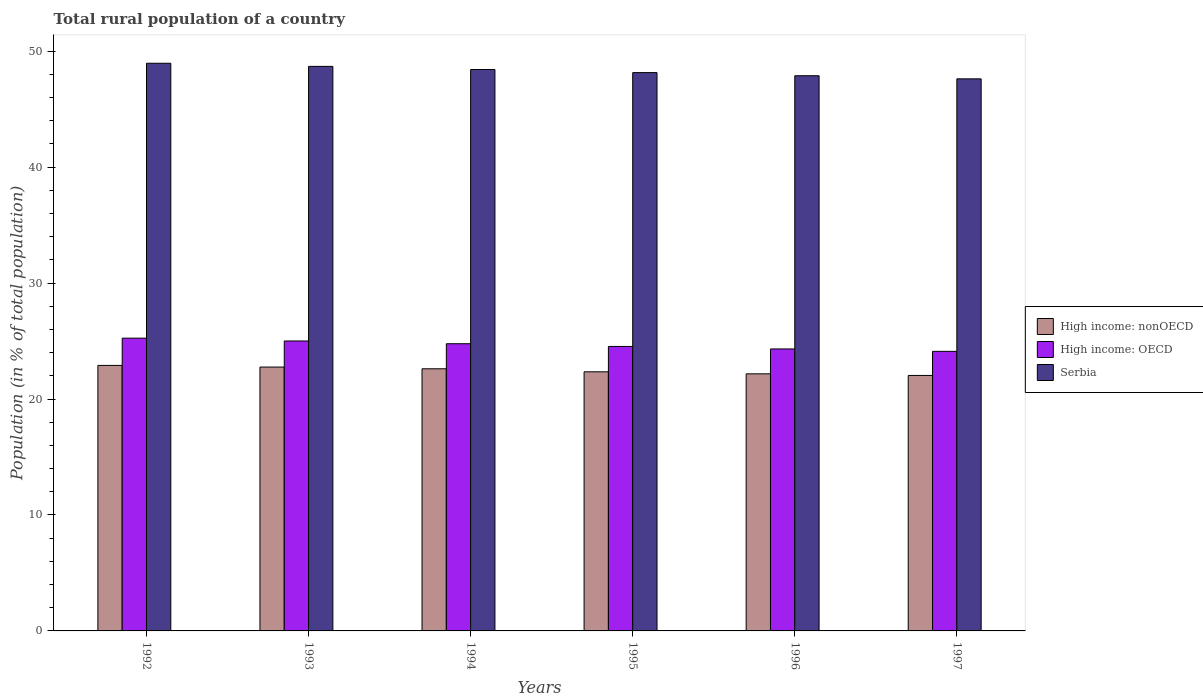How many different coloured bars are there?
Keep it short and to the point. 3. How many bars are there on the 5th tick from the left?
Your answer should be very brief. 3. What is the label of the 2nd group of bars from the left?
Provide a short and direct response. 1993. In how many cases, is the number of bars for a given year not equal to the number of legend labels?
Give a very brief answer. 0. What is the rural population in High income: OECD in 1994?
Provide a succinct answer. 24.77. Across all years, what is the maximum rural population in Serbia?
Give a very brief answer. 48.96. Across all years, what is the minimum rural population in High income: nonOECD?
Give a very brief answer. 22.04. In which year was the rural population in High income: OECD maximum?
Your answer should be very brief. 1992. In which year was the rural population in High income: nonOECD minimum?
Your answer should be very brief. 1997. What is the total rural population in High income: OECD in the graph?
Offer a terse response. 148. What is the difference between the rural population in High income: nonOECD in 1995 and that in 1996?
Ensure brevity in your answer.  0.17. What is the difference between the rural population in High income: OECD in 1993 and the rural population in Serbia in 1995?
Ensure brevity in your answer.  -23.15. What is the average rural population in High income: nonOECD per year?
Your answer should be compact. 22.47. In the year 1996, what is the difference between the rural population in Serbia and rural population in High income: OECD?
Offer a terse response. 23.56. What is the ratio of the rural population in Serbia in 1995 to that in 1996?
Offer a very short reply. 1.01. What is the difference between the highest and the second highest rural population in High income: nonOECD?
Offer a terse response. 0.14. What is the difference between the highest and the lowest rural population in High income: nonOECD?
Your answer should be very brief. 0.87. Is the sum of the rural population in Serbia in 1993 and 1995 greater than the maximum rural population in High income: nonOECD across all years?
Provide a short and direct response. Yes. What does the 1st bar from the left in 1993 represents?
Provide a succinct answer. High income: nonOECD. What does the 2nd bar from the right in 1995 represents?
Offer a terse response. High income: OECD. Are all the bars in the graph horizontal?
Your response must be concise. No. What is the difference between two consecutive major ticks on the Y-axis?
Give a very brief answer. 10. Does the graph contain any zero values?
Your answer should be compact. No. How many legend labels are there?
Give a very brief answer. 3. What is the title of the graph?
Provide a short and direct response. Total rural population of a country. Does "Austria" appear as one of the legend labels in the graph?
Make the answer very short. No. What is the label or title of the X-axis?
Ensure brevity in your answer.  Years. What is the label or title of the Y-axis?
Ensure brevity in your answer.  Population (in % of total population). What is the Population (in % of total population) of High income: nonOECD in 1992?
Provide a succinct answer. 22.9. What is the Population (in % of total population) of High income: OECD in 1992?
Give a very brief answer. 25.25. What is the Population (in % of total population) of Serbia in 1992?
Your answer should be very brief. 48.96. What is the Population (in % of total population) of High income: nonOECD in 1993?
Provide a short and direct response. 22.76. What is the Population (in % of total population) in High income: OECD in 1993?
Your answer should be very brief. 25.01. What is the Population (in % of total population) in Serbia in 1993?
Provide a short and direct response. 48.69. What is the Population (in % of total population) in High income: nonOECD in 1994?
Offer a very short reply. 22.61. What is the Population (in % of total population) of High income: OECD in 1994?
Provide a short and direct response. 24.77. What is the Population (in % of total population) in Serbia in 1994?
Your response must be concise. 48.42. What is the Population (in % of total population) in High income: nonOECD in 1995?
Keep it short and to the point. 22.35. What is the Population (in % of total population) of High income: OECD in 1995?
Provide a short and direct response. 24.54. What is the Population (in % of total population) in Serbia in 1995?
Your response must be concise. 48.16. What is the Population (in % of total population) of High income: nonOECD in 1996?
Provide a short and direct response. 22.18. What is the Population (in % of total population) of High income: OECD in 1996?
Ensure brevity in your answer.  24.32. What is the Population (in % of total population) of Serbia in 1996?
Provide a succinct answer. 47.89. What is the Population (in % of total population) of High income: nonOECD in 1997?
Give a very brief answer. 22.04. What is the Population (in % of total population) in High income: OECD in 1997?
Offer a very short reply. 24.11. What is the Population (in % of total population) in Serbia in 1997?
Make the answer very short. 47.62. Across all years, what is the maximum Population (in % of total population) in High income: nonOECD?
Offer a terse response. 22.9. Across all years, what is the maximum Population (in % of total population) in High income: OECD?
Keep it short and to the point. 25.25. Across all years, what is the maximum Population (in % of total population) of Serbia?
Keep it short and to the point. 48.96. Across all years, what is the minimum Population (in % of total population) of High income: nonOECD?
Your answer should be very brief. 22.04. Across all years, what is the minimum Population (in % of total population) in High income: OECD?
Your answer should be very brief. 24.11. Across all years, what is the minimum Population (in % of total population) in Serbia?
Your answer should be compact. 47.62. What is the total Population (in % of total population) in High income: nonOECD in the graph?
Your answer should be very brief. 134.83. What is the total Population (in % of total population) of High income: OECD in the graph?
Offer a very short reply. 148. What is the total Population (in % of total population) of Serbia in the graph?
Make the answer very short. 289.74. What is the difference between the Population (in % of total population) of High income: nonOECD in 1992 and that in 1993?
Offer a terse response. 0.14. What is the difference between the Population (in % of total population) in High income: OECD in 1992 and that in 1993?
Keep it short and to the point. 0.24. What is the difference between the Population (in % of total population) in Serbia in 1992 and that in 1993?
Provide a short and direct response. 0.27. What is the difference between the Population (in % of total population) in High income: nonOECD in 1992 and that in 1994?
Provide a short and direct response. 0.29. What is the difference between the Population (in % of total population) in High income: OECD in 1992 and that in 1994?
Make the answer very short. 0.48. What is the difference between the Population (in % of total population) of Serbia in 1992 and that in 1994?
Make the answer very short. 0.54. What is the difference between the Population (in % of total population) in High income: nonOECD in 1992 and that in 1995?
Offer a terse response. 0.55. What is the difference between the Population (in % of total population) of High income: OECD in 1992 and that in 1995?
Your response must be concise. 0.71. What is the difference between the Population (in % of total population) in Serbia in 1992 and that in 1995?
Give a very brief answer. 0.81. What is the difference between the Population (in % of total population) in High income: nonOECD in 1992 and that in 1996?
Provide a short and direct response. 0.73. What is the difference between the Population (in % of total population) in High income: OECD in 1992 and that in 1996?
Provide a succinct answer. 0.93. What is the difference between the Population (in % of total population) of Serbia in 1992 and that in 1996?
Your response must be concise. 1.08. What is the difference between the Population (in % of total population) of High income: nonOECD in 1992 and that in 1997?
Your response must be concise. 0.87. What is the difference between the Population (in % of total population) of High income: OECD in 1992 and that in 1997?
Offer a terse response. 1.14. What is the difference between the Population (in % of total population) of Serbia in 1992 and that in 1997?
Provide a succinct answer. 1.34. What is the difference between the Population (in % of total population) of High income: nonOECD in 1993 and that in 1994?
Make the answer very short. 0.15. What is the difference between the Population (in % of total population) of High income: OECD in 1993 and that in 1994?
Offer a very short reply. 0.24. What is the difference between the Population (in % of total population) of Serbia in 1993 and that in 1994?
Keep it short and to the point. 0.27. What is the difference between the Population (in % of total population) in High income: nonOECD in 1993 and that in 1995?
Offer a very short reply. 0.41. What is the difference between the Population (in % of total population) in High income: OECD in 1993 and that in 1995?
Offer a very short reply. 0.47. What is the difference between the Population (in % of total population) in Serbia in 1993 and that in 1995?
Your answer should be very brief. 0.54. What is the difference between the Population (in % of total population) in High income: nonOECD in 1993 and that in 1996?
Keep it short and to the point. 0.58. What is the difference between the Population (in % of total population) of High income: OECD in 1993 and that in 1996?
Ensure brevity in your answer.  0.69. What is the difference between the Population (in % of total population) in Serbia in 1993 and that in 1996?
Offer a very short reply. 0.81. What is the difference between the Population (in % of total population) in High income: nonOECD in 1993 and that in 1997?
Provide a short and direct response. 0.72. What is the difference between the Population (in % of total population) of High income: OECD in 1993 and that in 1997?
Offer a terse response. 0.89. What is the difference between the Population (in % of total population) in Serbia in 1993 and that in 1997?
Your answer should be compact. 1.08. What is the difference between the Population (in % of total population) in High income: nonOECD in 1994 and that in 1995?
Ensure brevity in your answer.  0.26. What is the difference between the Population (in % of total population) in High income: OECD in 1994 and that in 1995?
Provide a succinct answer. 0.23. What is the difference between the Population (in % of total population) of Serbia in 1994 and that in 1995?
Give a very brief answer. 0.27. What is the difference between the Population (in % of total population) of High income: nonOECD in 1994 and that in 1996?
Your response must be concise. 0.43. What is the difference between the Population (in % of total population) in High income: OECD in 1994 and that in 1996?
Keep it short and to the point. 0.45. What is the difference between the Population (in % of total population) in Serbia in 1994 and that in 1996?
Give a very brief answer. 0.54. What is the difference between the Population (in % of total population) in High income: nonOECD in 1994 and that in 1997?
Keep it short and to the point. 0.57. What is the difference between the Population (in % of total population) of High income: OECD in 1994 and that in 1997?
Ensure brevity in your answer.  0.66. What is the difference between the Population (in % of total population) in Serbia in 1994 and that in 1997?
Your answer should be compact. 0.81. What is the difference between the Population (in % of total population) of High income: nonOECD in 1995 and that in 1996?
Keep it short and to the point. 0.17. What is the difference between the Population (in % of total population) in High income: OECD in 1995 and that in 1996?
Your response must be concise. 0.22. What is the difference between the Population (in % of total population) in Serbia in 1995 and that in 1996?
Your answer should be compact. 0.27. What is the difference between the Population (in % of total population) of High income: nonOECD in 1995 and that in 1997?
Ensure brevity in your answer.  0.31. What is the difference between the Population (in % of total population) in High income: OECD in 1995 and that in 1997?
Offer a terse response. 0.42. What is the difference between the Population (in % of total population) in Serbia in 1995 and that in 1997?
Your response must be concise. 0.54. What is the difference between the Population (in % of total population) in High income: nonOECD in 1996 and that in 1997?
Offer a very short reply. 0.14. What is the difference between the Population (in % of total population) of High income: OECD in 1996 and that in 1997?
Your response must be concise. 0.21. What is the difference between the Population (in % of total population) of Serbia in 1996 and that in 1997?
Provide a succinct answer. 0.27. What is the difference between the Population (in % of total population) in High income: nonOECD in 1992 and the Population (in % of total population) in High income: OECD in 1993?
Your answer should be very brief. -2.11. What is the difference between the Population (in % of total population) in High income: nonOECD in 1992 and the Population (in % of total population) in Serbia in 1993?
Ensure brevity in your answer.  -25.79. What is the difference between the Population (in % of total population) of High income: OECD in 1992 and the Population (in % of total population) of Serbia in 1993?
Make the answer very short. -23.44. What is the difference between the Population (in % of total population) of High income: nonOECD in 1992 and the Population (in % of total population) of High income: OECD in 1994?
Offer a very short reply. -1.87. What is the difference between the Population (in % of total population) of High income: nonOECD in 1992 and the Population (in % of total population) of Serbia in 1994?
Your answer should be compact. -25.52. What is the difference between the Population (in % of total population) of High income: OECD in 1992 and the Population (in % of total population) of Serbia in 1994?
Keep it short and to the point. -23.17. What is the difference between the Population (in % of total population) of High income: nonOECD in 1992 and the Population (in % of total population) of High income: OECD in 1995?
Offer a very short reply. -1.64. What is the difference between the Population (in % of total population) of High income: nonOECD in 1992 and the Population (in % of total population) of Serbia in 1995?
Provide a succinct answer. -25.26. What is the difference between the Population (in % of total population) of High income: OECD in 1992 and the Population (in % of total population) of Serbia in 1995?
Your answer should be compact. -22.91. What is the difference between the Population (in % of total population) in High income: nonOECD in 1992 and the Population (in % of total population) in High income: OECD in 1996?
Provide a succinct answer. -1.42. What is the difference between the Population (in % of total population) of High income: nonOECD in 1992 and the Population (in % of total population) of Serbia in 1996?
Offer a terse response. -24.99. What is the difference between the Population (in % of total population) in High income: OECD in 1992 and the Population (in % of total population) in Serbia in 1996?
Provide a succinct answer. -22.64. What is the difference between the Population (in % of total population) in High income: nonOECD in 1992 and the Population (in % of total population) in High income: OECD in 1997?
Provide a succinct answer. -1.21. What is the difference between the Population (in % of total population) in High income: nonOECD in 1992 and the Population (in % of total population) in Serbia in 1997?
Keep it short and to the point. -24.72. What is the difference between the Population (in % of total population) in High income: OECD in 1992 and the Population (in % of total population) in Serbia in 1997?
Ensure brevity in your answer.  -22.37. What is the difference between the Population (in % of total population) of High income: nonOECD in 1993 and the Population (in % of total population) of High income: OECD in 1994?
Make the answer very short. -2.01. What is the difference between the Population (in % of total population) in High income: nonOECD in 1993 and the Population (in % of total population) in Serbia in 1994?
Offer a terse response. -25.67. What is the difference between the Population (in % of total population) in High income: OECD in 1993 and the Population (in % of total population) in Serbia in 1994?
Provide a succinct answer. -23.42. What is the difference between the Population (in % of total population) in High income: nonOECD in 1993 and the Population (in % of total population) in High income: OECD in 1995?
Give a very brief answer. -1.78. What is the difference between the Population (in % of total population) in High income: nonOECD in 1993 and the Population (in % of total population) in Serbia in 1995?
Make the answer very short. -25.4. What is the difference between the Population (in % of total population) of High income: OECD in 1993 and the Population (in % of total population) of Serbia in 1995?
Your answer should be very brief. -23.15. What is the difference between the Population (in % of total population) of High income: nonOECD in 1993 and the Population (in % of total population) of High income: OECD in 1996?
Keep it short and to the point. -1.56. What is the difference between the Population (in % of total population) of High income: nonOECD in 1993 and the Population (in % of total population) of Serbia in 1996?
Your answer should be compact. -25.13. What is the difference between the Population (in % of total population) in High income: OECD in 1993 and the Population (in % of total population) in Serbia in 1996?
Your answer should be compact. -22.88. What is the difference between the Population (in % of total population) of High income: nonOECD in 1993 and the Population (in % of total population) of High income: OECD in 1997?
Ensure brevity in your answer.  -1.36. What is the difference between the Population (in % of total population) in High income: nonOECD in 1993 and the Population (in % of total population) in Serbia in 1997?
Offer a terse response. -24.86. What is the difference between the Population (in % of total population) of High income: OECD in 1993 and the Population (in % of total population) of Serbia in 1997?
Provide a succinct answer. -22.61. What is the difference between the Population (in % of total population) of High income: nonOECD in 1994 and the Population (in % of total population) of High income: OECD in 1995?
Ensure brevity in your answer.  -1.93. What is the difference between the Population (in % of total population) in High income: nonOECD in 1994 and the Population (in % of total population) in Serbia in 1995?
Offer a very short reply. -25.55. What is the difference between the Population (in % of total population) in High income: OECD in 1994 and the Population (in % of total population) in Serbia in 1995?
Your response must be concise. -23.38. What is the difference between the Population (in % of total population) of High income: nonOECD in 1994 and the Population (in % of total population) of High income: OECD in 1996?
Keep it short and to the point. -1.71. What is the difference between the Population (in % of total population) in High income: nonOECD in 1994 and the Population (in % of total population) in Serbia in 1996?
Provide a succinct answer. -25.28. What is the difference between the Population (in % of total population) in High income: OECD in 1994 and the Population (in % of total population) in Serbia in 1996?
Offer a terse response. -23.11. What is the difference between the Population (in % of total population) of High income: nonOECD in 1994 and the Population (in % of total population) of High income: OECD in 1997?
Your answer should be very brief. -1.5. What is the difference between the Population (in % of total population) of High income: nonOECD in 1994 and the Population (in % of total population) of Serbia in 1997?
Give a very brief answer. -25.01. What is the difference between the Population (in % of total population) in High income: OECD in 1994 and the Population (in % of total population) in Serbia in 1997?
Provide a short and direct response. -22.85. What is the difference between the Population (in % of total population) in High income: nonOECD in 1995 and the Population (in % of total population) in High income: OECD in 1996?
Your response must be concise. -1.97. What is the difference between the Population (in % of total population) in High income: nonOECD in 1995 and the Population (in % of total population) in Serbia in 1996?
Give a very brief answer. -25.54. What is the difference between the Population (in % of total population) of High income: OECD in 1995 and the Population (in % of total population) of Serbia in 1996?
Offer a very short reply. -23.35. What is the difference between the Population (in % of total population) of High income: nonOECD in 1995 and the Population (in % of total population) of High income: OECD in 1997?
Offer a very short reply. -1.76. What is the difference between the Population (in % of total population) of High income: nonOECD in 1995 and the Population (in % of total population) of Serbia in 1997?
Provide a succinct answer. -25.27. What is the difference between the Population (in % of total population) in High income: OECD in 1995 and the Population (in % of total population) in Serbia in 1997?
Give a very brief answer. -23.08. What is the difference between the Population (in % of total population) of High income: nonOECD in 1996 and the Population (in % of total population) of High income: OECD in 1997?
Provide a succinct answer. -1.94. What is the difference between the Population (in % of total population) of High income: nonOECD in 1996 and the Population (in % of total population) of Serbia in 1997?
Keep it short and to the point. -25.44. What is the difference between the Population (in % of total population) in High income: OECD in 1996 and the Population (in % of total population) in Serbia in 1997?
Keep it short and to the point. -23.3. What is the average Population (in % of total population) of High income: nonOECD per year?
Offer a terse response. 22.47. What is the average Population (in % of total population) of High income: OECD per year?
Offer a very short reply. 24.67. What is the average Population (in % of total population) of Serbia per year?
Your answer should be very brief. 48.29. In the year 1992, what is the difference between the Population (in % of total population) in High income: nonOECD and Population (in % of total population) in High income: OECD?
Provide a short and direct response. -2.35. In the year 1992, what is the difference between the Population (in % of total population) of High income: nonOECD and Population (in % of total population) of Serbia?
Keep it short and to the point. -26.06. In the year 1992, what is the difference between the Population (in % of total population) of High income: OECD and Population (in % of total population) of Serbia?
Offer a terse response. -23.71. In the year 1993, what is the difference between the Population (in % of total population) of High income: nonOECD and Population (in % of total population) of High income: OECD?
Provide a succinct answer. -2.25. In the year 1993, what is the difference between the Population (in % of total population) in High income: nonOECD and Population (in % of total population) in Serbia?
Your answer should be very brief. -25.94. In the year 1993, what is the difference between the Population (in % of total population) in High income: OECD and Population (in % of total population) in Serbia?
Keep it short and to the point. -23.69. In the year 1994, what is the difference between the Population (in % of total population) of High income: nonOECD and Population (in % of total population) of High income: OECD?
Your response must be concise. -2.16. In the year 1994, what is the difference between the Population (in % of total population) in High income: nonOECD and Population (in % of total population) in Serbia?
Give a very brief answer. -25.81. In the year 1994, what is the difference between the Population (in % of total population) in High income: OECD and Population (in % of total population) in Serbia?
Provide a short and direct response. -23.65. In the year 1995, what is the difference between the Population (in % of total population) in High income: nonOECD and Population (in % of total population) in High income: OECD?
Provide a short and direct response. -2.19. In the year 1995, what is the difference between the Population (in % of total population) of High income: nonOECD and Population (in % of total population) of Serbia?
Your response must be concise. -25.81. In the year 1995, what is the difference between the Population (in % of total population) of High income: OECD and Population (in % of total population) of Serbia?
Your response must be concise. -23.62. In the year 1996, what is the difference between the Population (in % of total population) of High income: nonOECD and Population (in % of total population) of High income: OECD?
Make the answer very short. -2.15. In the year 1996, what is the difference between the Population (in % of total population) in High income: nonOECD and Population (in % of total population) in Serbia?
Provide a short and direct response. -25.71. In the year 1996, what is the difference between the Population (in % of total population) in High income: OECD and Population (in % of total population) in Serbia?
Give a very brief answer. -23.56. In the year 1997, what is the difference between the Population (in % of total population) in High income: nonOECD and Population (in % of total population) in High income: OECD?
Ensure brevity in your answer.  -2.08. In the year 1997, what is the difference between the Population (in % of total population) of High income: nonOECD and Population (in % of total population) of Serbia?
Provide a short and direct response. -25.58. In the year 1997, what is the difference between the Population (in % of total population) in High income: OECD and Population (in % of total population) in Serbia?
Offer a terse response. -23.5. What is the ratio of the Population (in % of total population) of High income: nonOECD in 1992 to that in 1993?
Your answer should be compact. 1.01. What is the ratio of the Population (in % of total population) of High income: OECD in 1992 to that in 1993?
Make the answer very short. 1.01. What is the ratio of the Population (in % of total population) in High income: nonOECD in 1992 to that in 1994?
Make the answer very short. 1.01. What is the ratio of the Population (in % of total population) in High income: OECD in 1992 to that in 1994?
Your response must be concise. 1.02. What is the ratio of the Population (in % of total population) of Serbia in 1992 to that in 1994?
Your answer should be compact. 1.01. What is the ratio of the Population (in % of total population) in High income: nonOECD in 1992 to that in 1995?
Offer a very short reply. 1.02. What is the ratio of the Population (in % of total population) of High income: OECD in 1992 to that in 1995?
Your answer should be very brief. 1.03. What is the ratio of the Population (in % of total population) in Serbia in 1992 to that in 1995?
Make the answer very short. 1.02. What is the ratio of the Population (in % of total population) in High income: nonOECD in 1992 to that in 1996?
Give a very brief answer. 1.03. What is the ratio of the Population (in % of total population) of High income: OECD in 1992 to that in 1996?
Offer a terse response. 1.04. What is the ratio of the Population (in % of total population) in Serbia in 1992 to that in 1996?
Provide a short and direct response. 1.02. What is the ratio of the Population (in % of total population) of High income: nonOECD in 1992 to that in 1997?
Your response must be concise. 1.04. What is the ratio of the Population (in % of total population) of High income: OECD in 1992 to that in 1997?
Offer a terse response. 1.05. What is the ratio of the Population (in % of total population) of Serbia in 1992 to that in 1997?
Ensure brevity in your answer.  1.03. What is the ratio of the Population (in % of total population) of High income: nonOECD in 1993 to that in 1994?
Keep it short and to the point. 1.01. What is the ratio of the Population (in % of total population) in High income: OECD in 1993 to that in 1994?
Provide a short and direct response. 1.01. What is the ratio of the Population (in % of total population) of Serbia in 1993 to that in 1994?
Provide a succinct answer. 1.01. What is the ratio of the Population (in % of total population) in High income: nonOECD in 1993 to that in 1995?
Your response must be concise. 1.02. What is the ratio of the Population (in % of total population) in High income: OECD in 1993 to that in 1995?
Give a very brief answer. 1.02. What is the ratio of the Population (in % of total population) of Serbia in 1993 to that in 1995?
Ensure brevity in your answer.  1.01. What is the ratio of the Population (in % of total population) of High income: nonOECD in 1993 to that in 1996?
Your response must be concise. 1.03. What is the ratio of the Population (in % of total population) of High income: OECD in 1993 to that in 1996?
Your response must be concise. 1.03. What is the ratio of the Population (in % of total population) in Serbia in 1993 to that in 1996?
Give a very brief answer. 1.02. What is the ratio of the Population (in % of total population) of High income: nonOECD in 1993 to that in 1997?
Give a very brief answer. 1.03. What is the ratio of the Population (in % of total population) in High income: OECD in 1993 to that in 1997?
Your answer should be compact. 1.04. What is the ratio of the Population (in % of total population) in Serbia in 1993 to that in 1997?
Ensure brevity in your answer.  1.02. What is the ratio of the Population (in % of total population) in High income: nonOECD in 1994 to that in 1995?
Make the answer very short. 1.01. What is the ratio of the Population (in % of total population) of High income: OECD in 1994 to that in 1995?
Make the answer very short. 1.01. What is the ratio of the Population (in % of total population) of Serbia in 1994 to that in 1995?
Your answer should be very brief. 1.01. What is the ratio of the Population (in % of total population) in High income: nonOECD in 1994 to that in 1996?
Keep it short and to the point. 1.02. What is the ratio of the Population (in % of total population) in High income: OECD in 1994 to that in 1996?
Your response must be concise. 1.02. What is the ratio of the Population (in % of total population) in Serbia in 1994 to that in 1996?
Your response must be concise. 1.01. What is the ratio of the Population (in % of total population) in High income: nonOECD in 1994 to that in 1997?
Provide a succinct answer. 1.03. What is the ratio of the Population (in % of total population) in High income: OECD in 1994 to that in 1997?
Give a very brief answer. 1.03. What is the ratio of the Population (in % of total population) of Serbia in 1994 to that in 1997?
Ensure brevity in your answer.  1.02. What is the ratio of the Population (in % of total population) of High income: nonOECD in 1995 to that in 1996?
Provide a short and direct response. 1.01. What is the ratio of the Population (in % of total population) of High income: OECD in 1995 to that in 1996?
Your response must be concise. 1.01. What is the ratio of the Population (in % of total population) of Serbia in 1995 to that in 1996?
Keep it short and to the point. 1.01. What is the ratio of the Population (in % of total population) of High income: nonOECD in 1995 to that in 1997?
Make the answer very short. 1.01. What is the ratio of the Population (in % of total population) in High income: OECD in 1995 to that in 1997?
Keep it short and to the point. 1.02. What is the ratio of the Population (in % of total population) of Serbia in 1995 to that in 1997?
Give a very brief answer. 1.01. What is the ratio of the Population (in % of total population) of High income: nonOECD in 1996 to that in 1997?
Your answer should be compact. 1.01. What is the ratio of the Population (in % of total population) in High income: OECD in 1996 to that in 1997?
Make the answer very short. 1.01. What is the ratio of the Population (in % of total population) of Serbia in 1996 to that in 1997?
Ensure brevity in your answer.  1.01. What is the difference between the highest and the second highest Population (in % of total population) in High income: nonOECD?
Provide a succinct answer. 0.14. What is the difference between the highest and the second highest Population (in % of total population) in High income: OECD?
Ensure brevity in your answer.  0.24. What is the difference between the highest and the second highest Population (in % of total population) in Serbia?
Offer a very short reply. 0.27. What is the difference between the highest and the lowest Population (in % of total population) of High income: nonOECD?
Offer a very short reply. 0.87. What is the difference between the highest and the lowest Population (in % of total population) in High income: OECD?
Your answer should be very brief. 1.14. What is the difference between the highest and the lowest Population (in % of total population) in Serbia?
Your answer should be very brief. 1.34. 